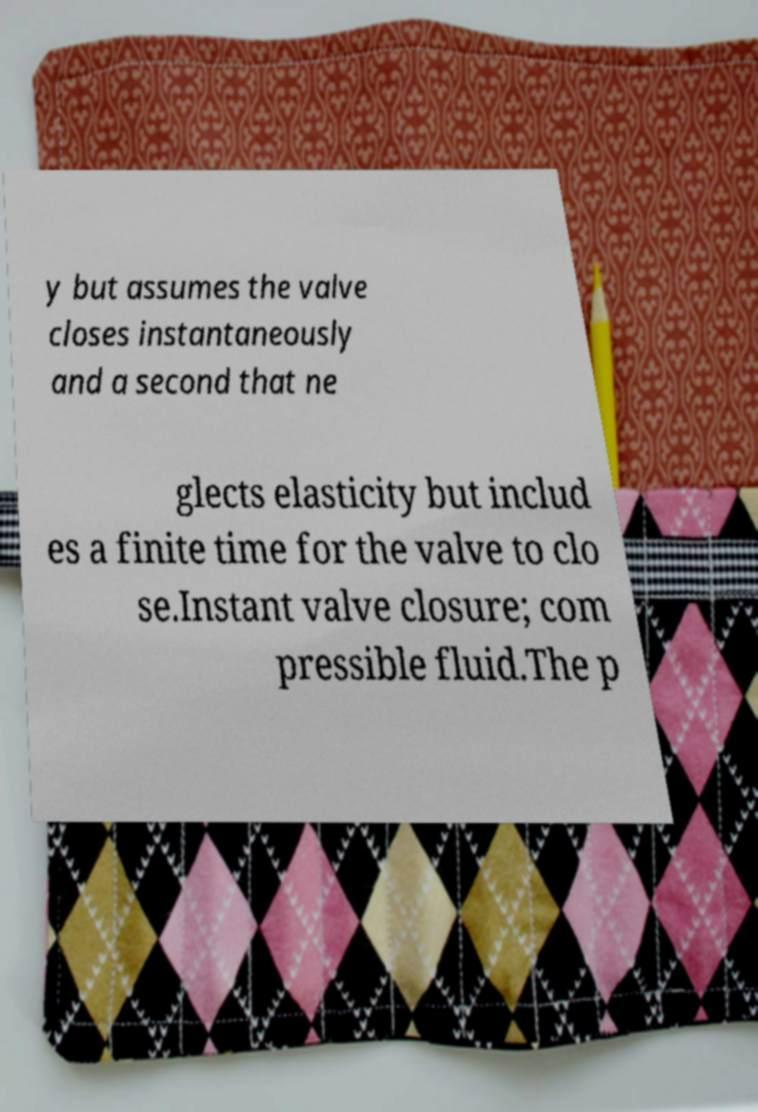Can you accurately transcribe the text from the provided image for me? y but assumes the valve closes instantaneously and a second that ne glects elasticity but includ es a finite time for the valve to clo se.Instant valve closure; com pressible fluid.The p 